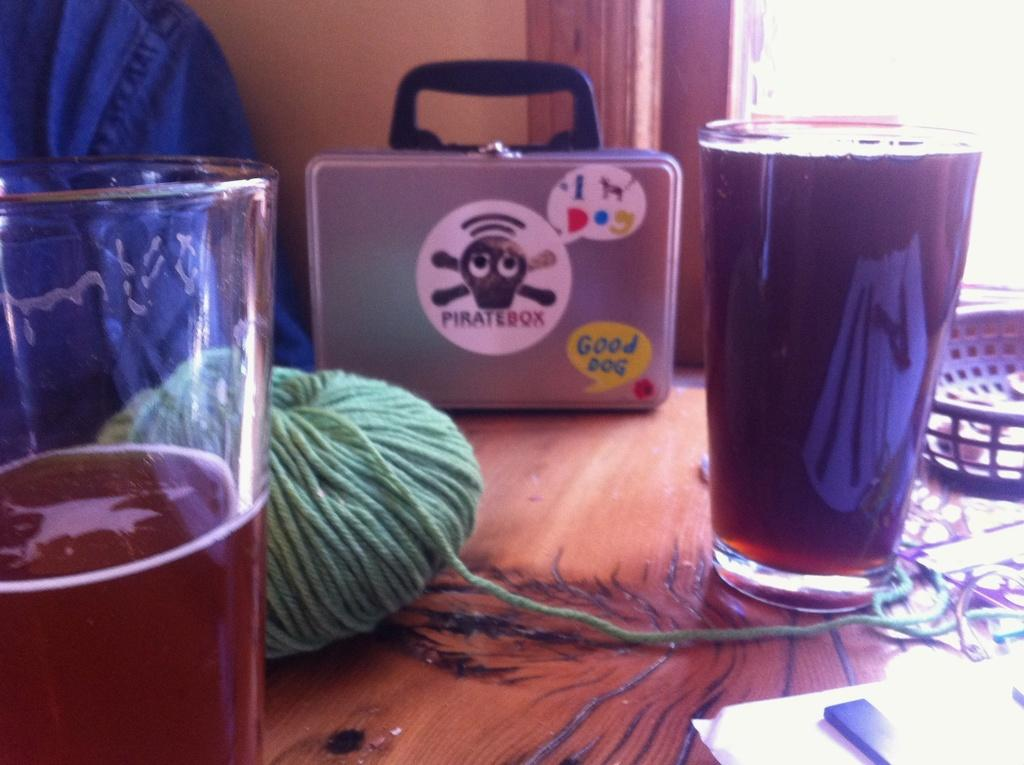<image>
Share a concise interpretation of the image provided. A silver case has a sticker that reads Pirate Box on the front. 